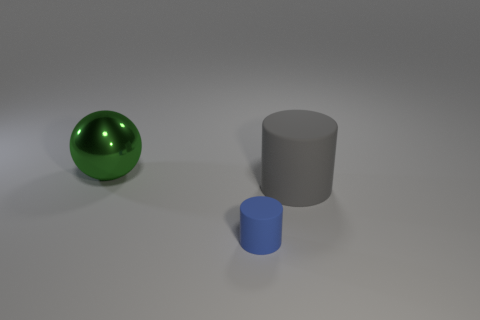There is a thing that is right of the matte thing that is in front of the cylinder that is on the right side of the tiny blue matte cylinder; what is its material?
Provide a succinct answer. Rubber. How many other objects are there of the same shape as the blue matte object?
Your answer should be very brief. 1. What color is the matte cylinder that is behind the tiny matte thing?
Offer a very short reply. Gray. There is a matte cylinder in front of the large object right of the green metal object; what number of gray cylinders are right of it?
Provide a short and direct response. 1. How many large matte objects are in front of the large thing that is in front of the large green metal thing?
Ensure brevity in your answer.  0. There is a green ball; what number of gray matte cylinders are to the left of it?
Provide a short and direct response. 0. What number of other things are there of the same size as the shiny thing?
Offer a terse response. 1. There is another rubber object that is the same shape as the gray object; what size is it?
Provide a succinct answer. Small. The large thing that is behind the gray cylinder has what shape?
Your answer should be very brief. Sphere. There is a object that is behind the cylinder that is on the right side of the blue matte cylinder; what color is it?
Ensure brevity in your answer.  Green. 